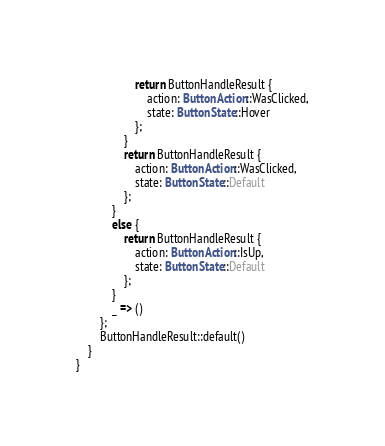<code> <loc_0><loc_0><loc_500><loc_500><_Rust_>                    return ButtonHandleResult {
                        action: ButtonAction::WasClicked,
                        state: ButtonState::Hover
                    };
                }
                return ButtonHandleResult {
                    action: ButtonAction::WasClicked,
                    state: ButtonState::Default
                };
            }
            else {
                return ButtonHandleResult {
                    action: ButtonAction::IsUp,
                    state: ButtonState::Default
                };
            }
            _ => ()
        };
        ButtonHandleResult::default()
    }
}
</code> 